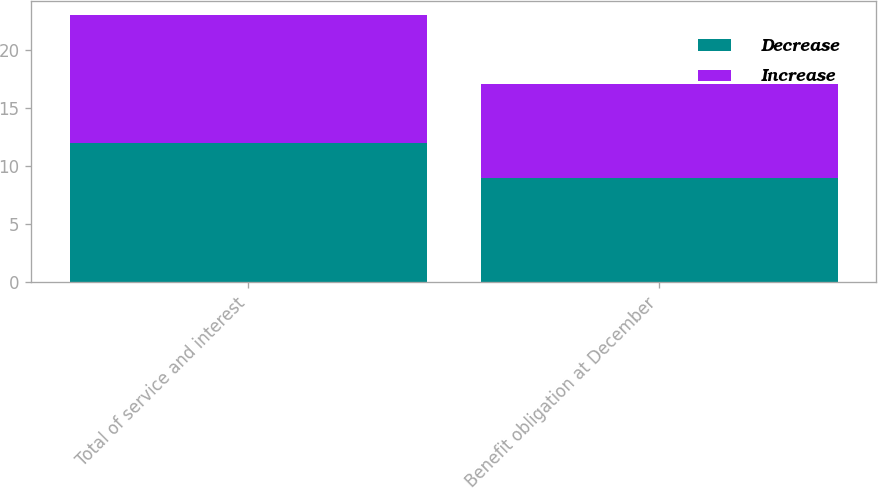<chart> <loc_0><loc_0><loc_500><loc_500><stacked_bar_chart><ecel><fcel>Total of service and interest<fcel>Benefit obligation at December<nl><fcel>Decrease<fcel>12<fcel>9<nl><fcel>Increase<fcel>11<fcel>8<nl></chart> 